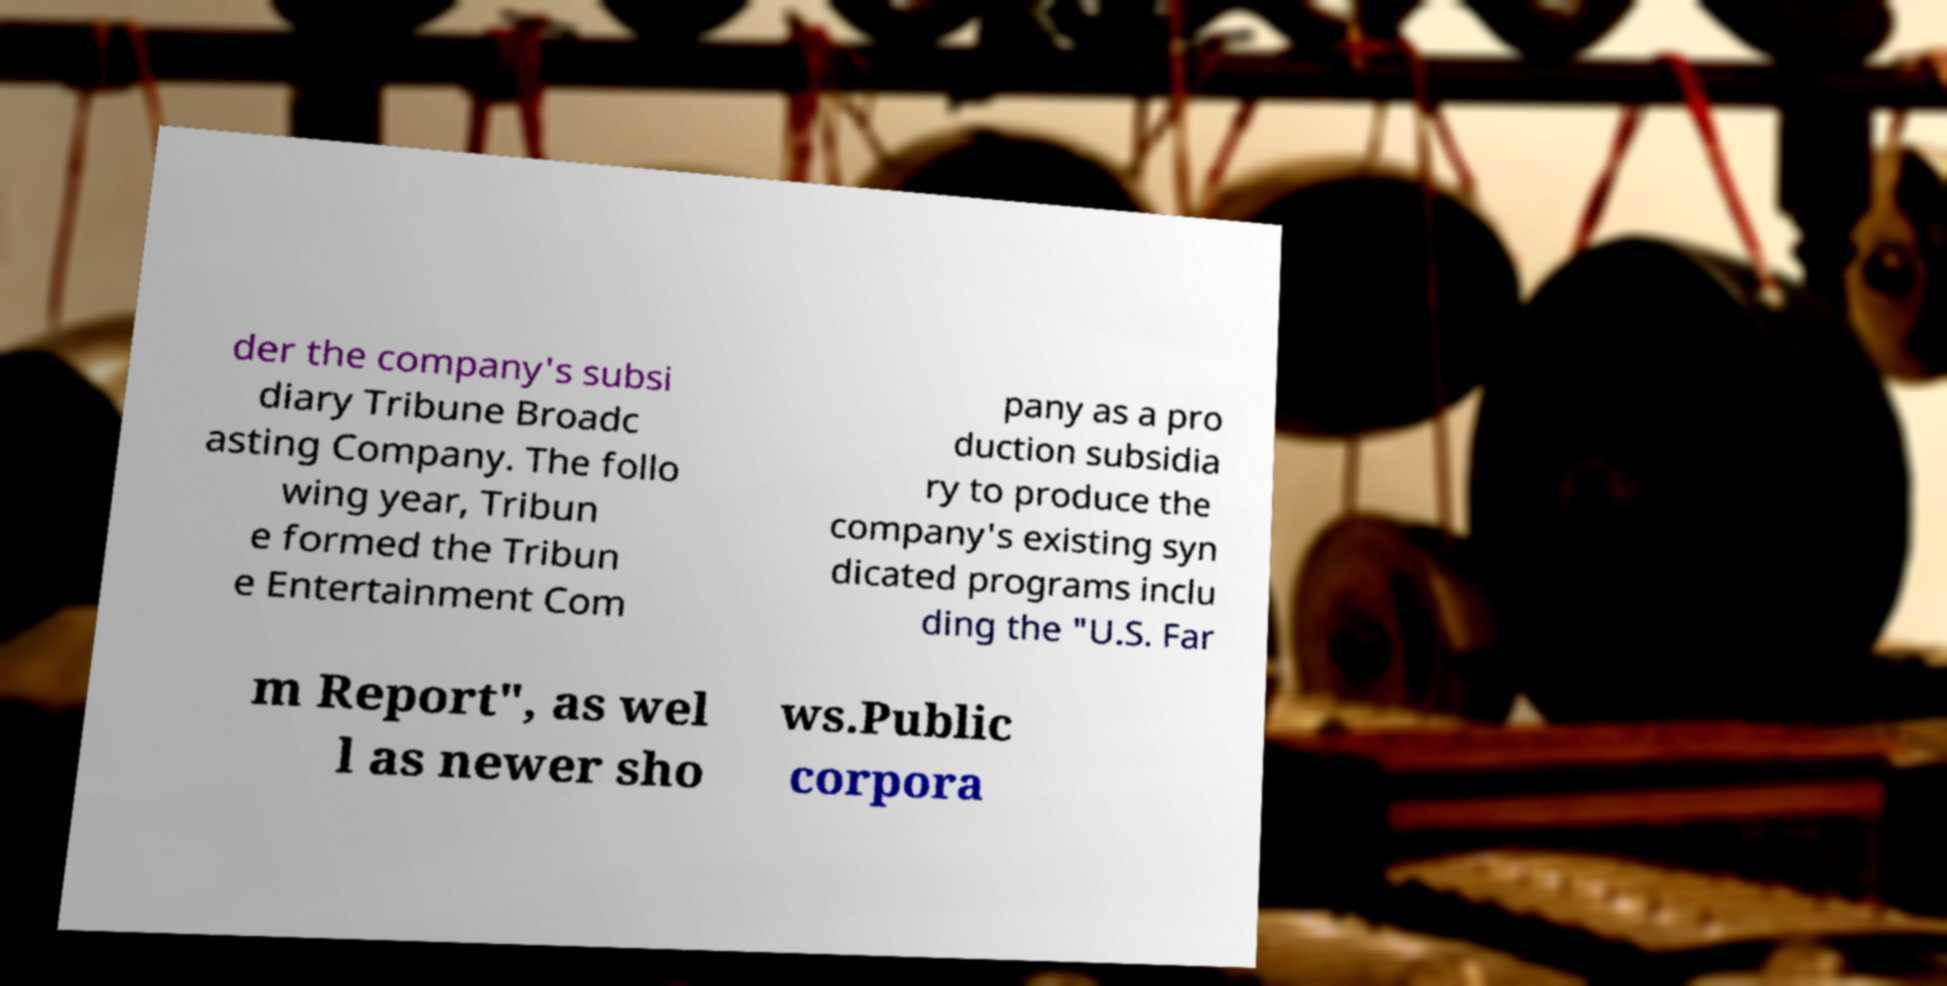For documentation purposes, I need the text within this image transcribed. Could you provide that? der the company's subsi diary Tribune Broadc asting Company. The follo wing year, Tribun e formed the Tribun e Entertainment Com pany as a pro duction subsidia ry to produce the company's existing syn dicated programs inclu ding the "U.S. Far m Report", as wel l as newer sho ws.Public corpora 